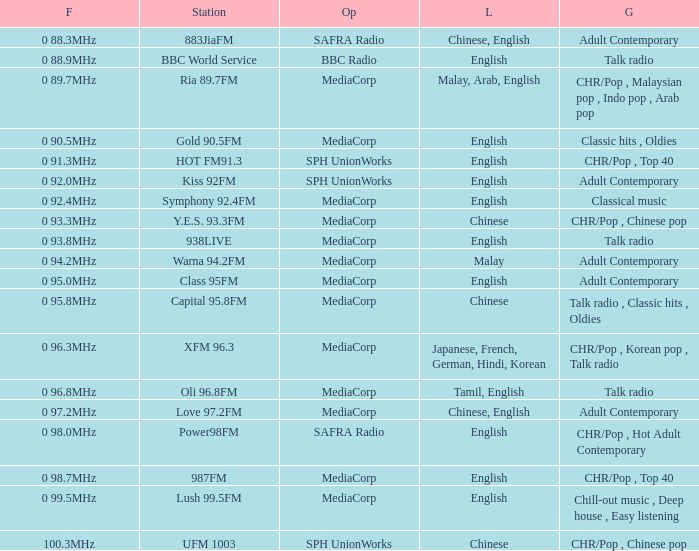Which genre can be found on a class 95fm station? Adult Contemporary. 